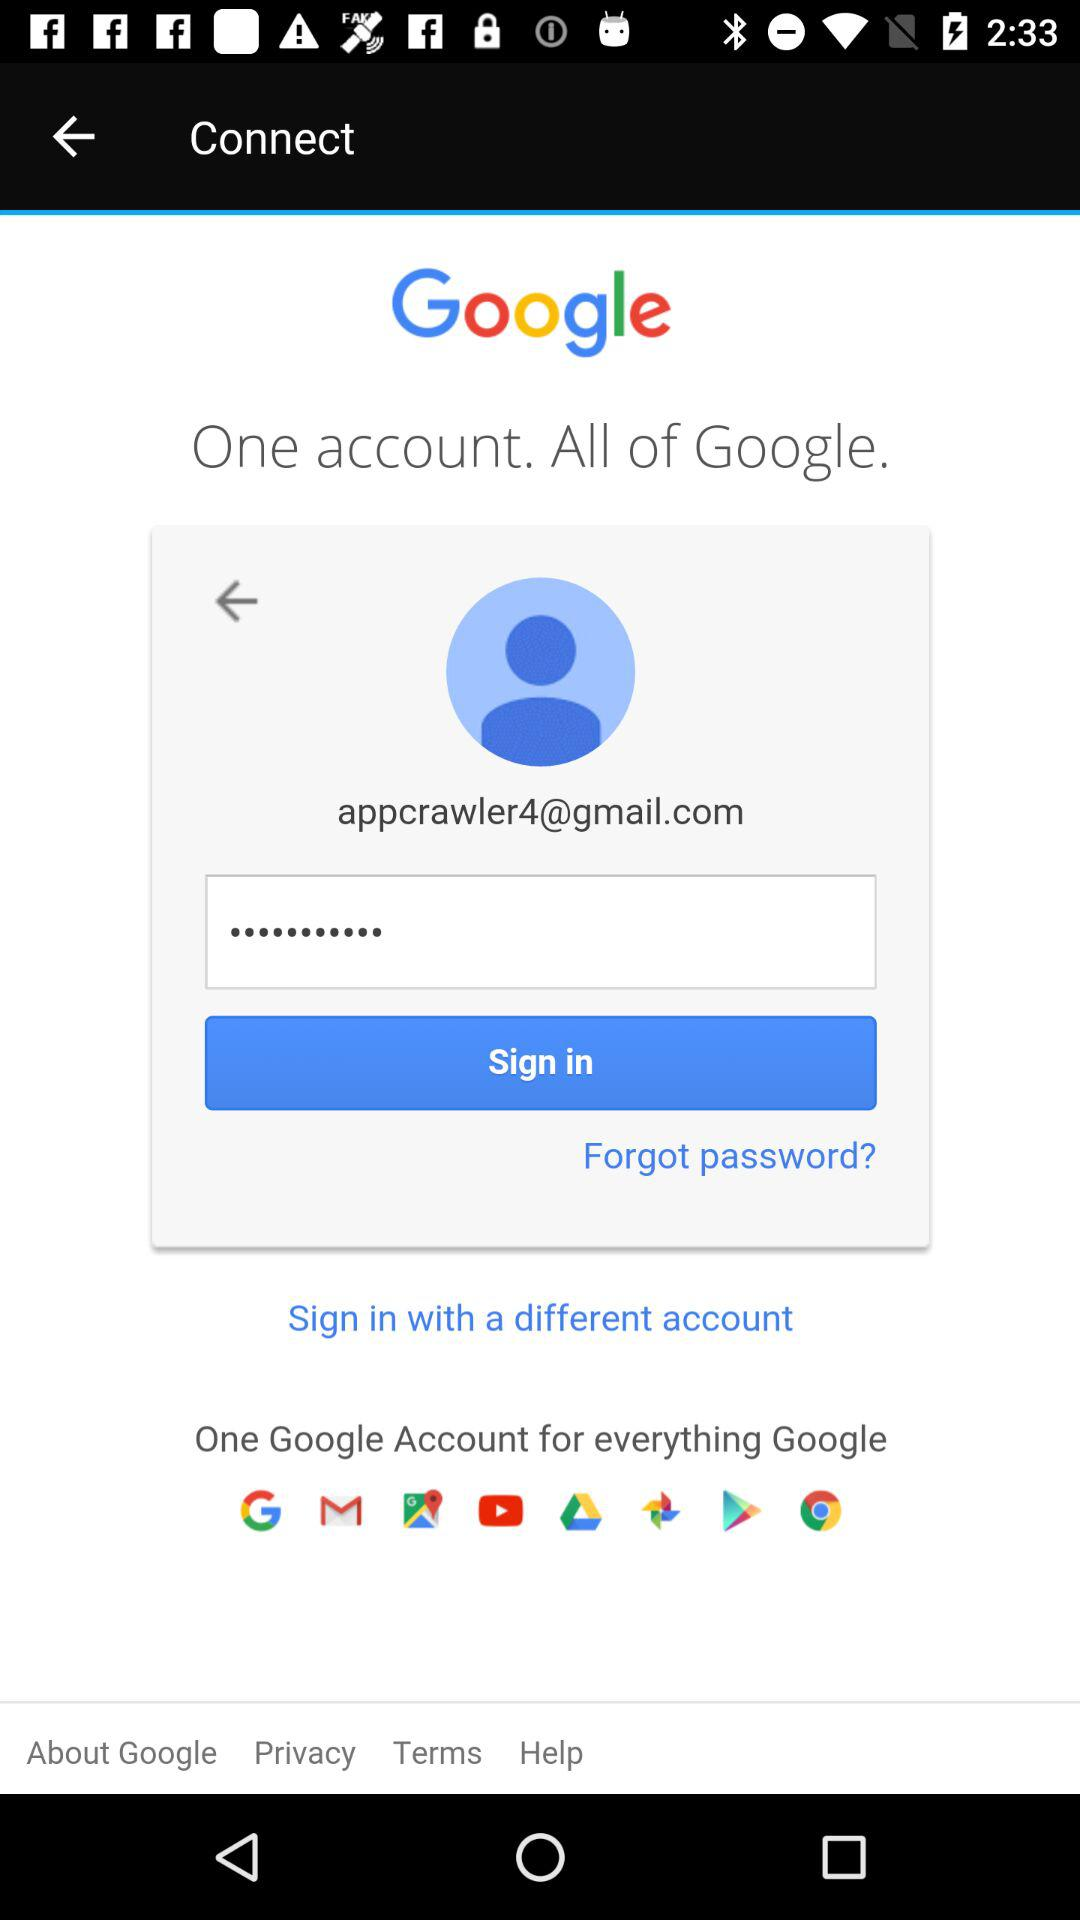What is the email address? The email address is appcrawler4@gmail.com. 